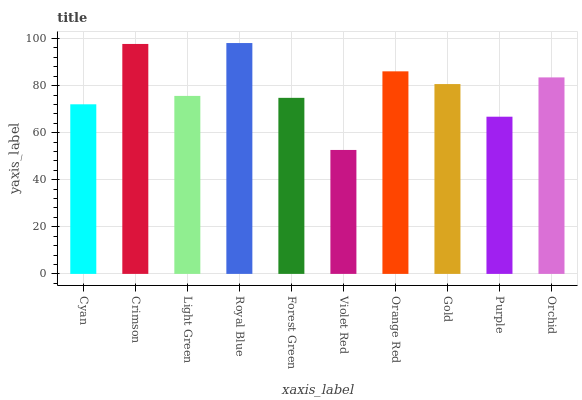Is Violet Red the minimum?
Answer yes or no. Yes. Is Royal Blue the maximum?
Answer yes or no. Yes. Is Crimson the minimum?
Answer yes or no. No. Is Crimson the maximum?
Answer yes or no. No. Is Crimson greater than Cyan?
Answer yes or no. Yes. Is Cyan less than Crimson?
Answer yes or no. Yes. Is Cyan greater than Crimson?
Answer yes or no. No. Is Crimson less than Cyan?
Answer yes or no. No. Is Gold the high median?
Answer yes or no. Yes. Is Light Green the low median?
Answer yes or no. Yes. Is Orange Red the high median?
Answer yes or no. No. Is Violet Red the low median?
Answer yes or no. No. 